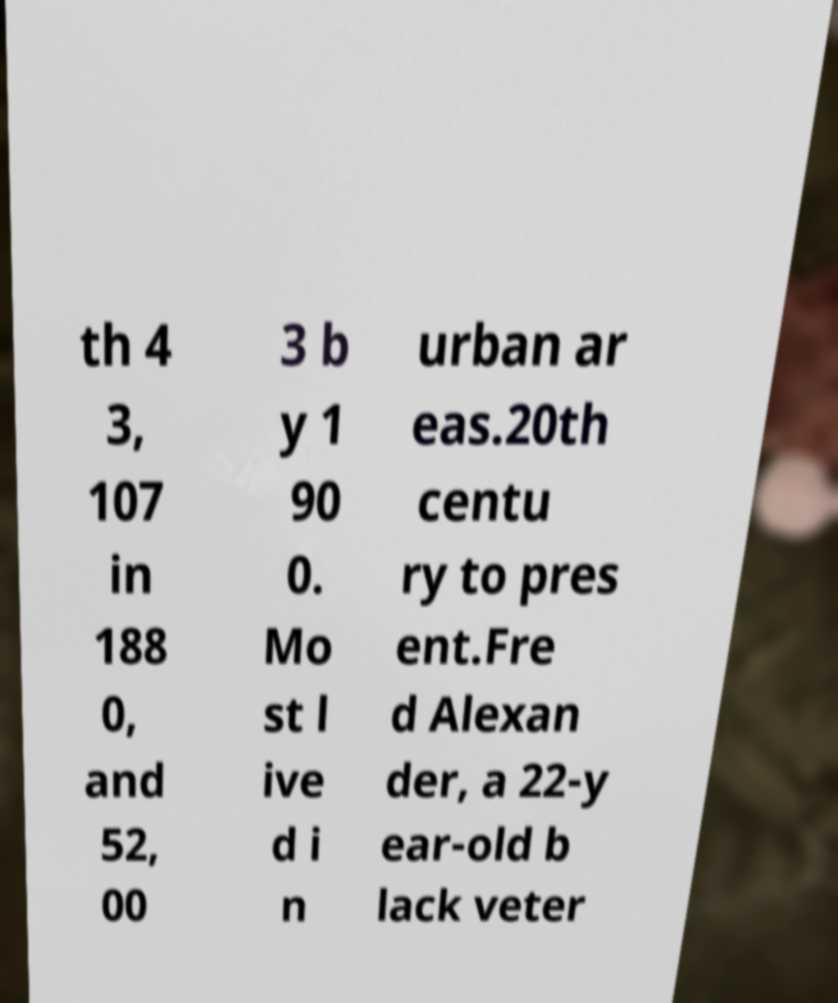Can you read and provide the text displayed in the image?This photo seems to have some interesting text. Can you extract and type it out for me? th 4 3, 107 in 188 0, and 52, 00 3 b y 1 90 0. Mo st l ive d i n urban ar eas.20th centu ry to pres ent.Fre d Alexan der, a 22-y ear-old b lack veter 